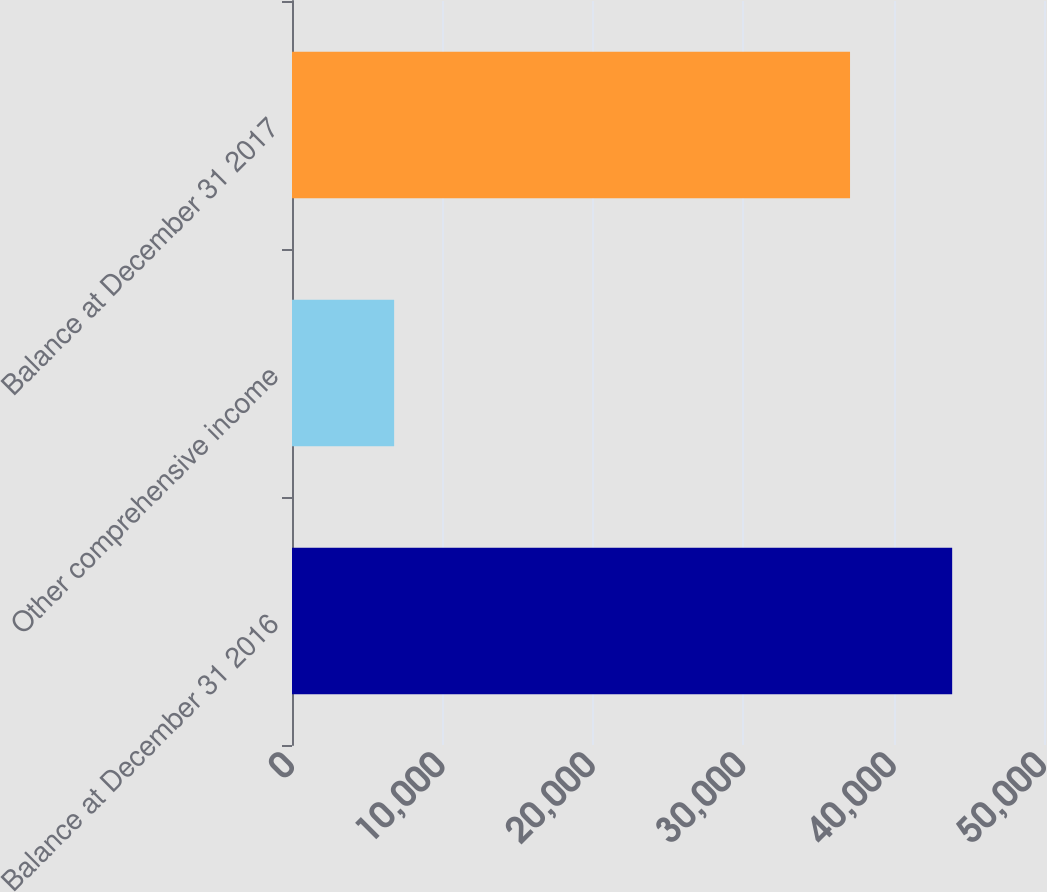<chart> <loc_0><loc_0><loc_500><loc_500><bar_chart><fcel>Balance at December 31 2016<fcel>Other comprehensive income<fcel>Balance at December 31 2017<nl><fcel>43894<fcel>6791<fcel>37103<nl></chart> 